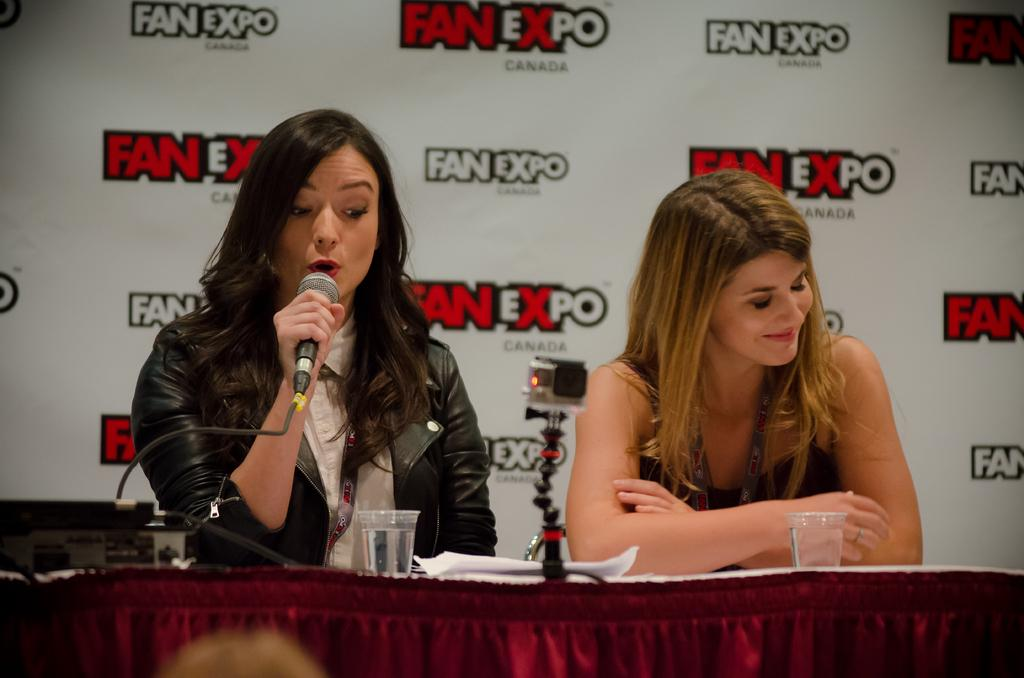Who is present at the table in the image? There are women sitting at the table in the image. What objects can be seen on the table? There is a camera, glasses, and a mic on the table. What is the purpose of the camera on the table? The purpose of the camera on the table is not specified in the image, but it could be used for photography or videography. What can be seen in the background of the image? There is an advertisement in the background. What flavor of eggs are being cooked in the middle of the image? There are no eggs present in the image, and therefore no such activity can be observed. 